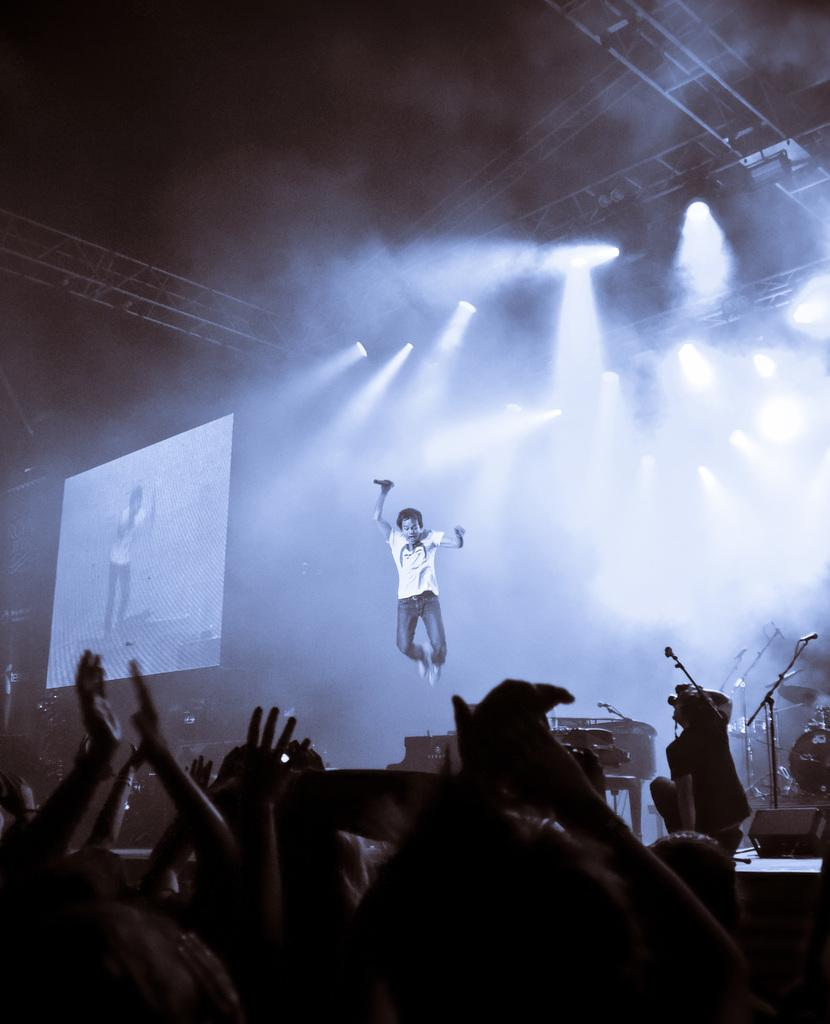What is the person in the air doing in the image? The person in the air is holding a microphone. Can you describe the other people in the image? There are people in the image, but their specific actions or roles are not clear. What objects related to music can be seen in the image? There are musical instruments in the image. What is the purpose of the screen in the image? The purpose of the screen in the image is not clear from the provided facts. What is the lighting situation in the image? Lights are visible in the image, and the background is dark. What type of quiver is the person in the air using to hold the microphone? There is no quiver present in the image; the person is simply holding the microphone. What kind of art can be seen on the screen in the image? There is no art visible on the screen in the image, as its purpose is not clear. What type of jewel is the person in the air wearing on their wrist? There is no jewelry visible on the person in the air in the image. 